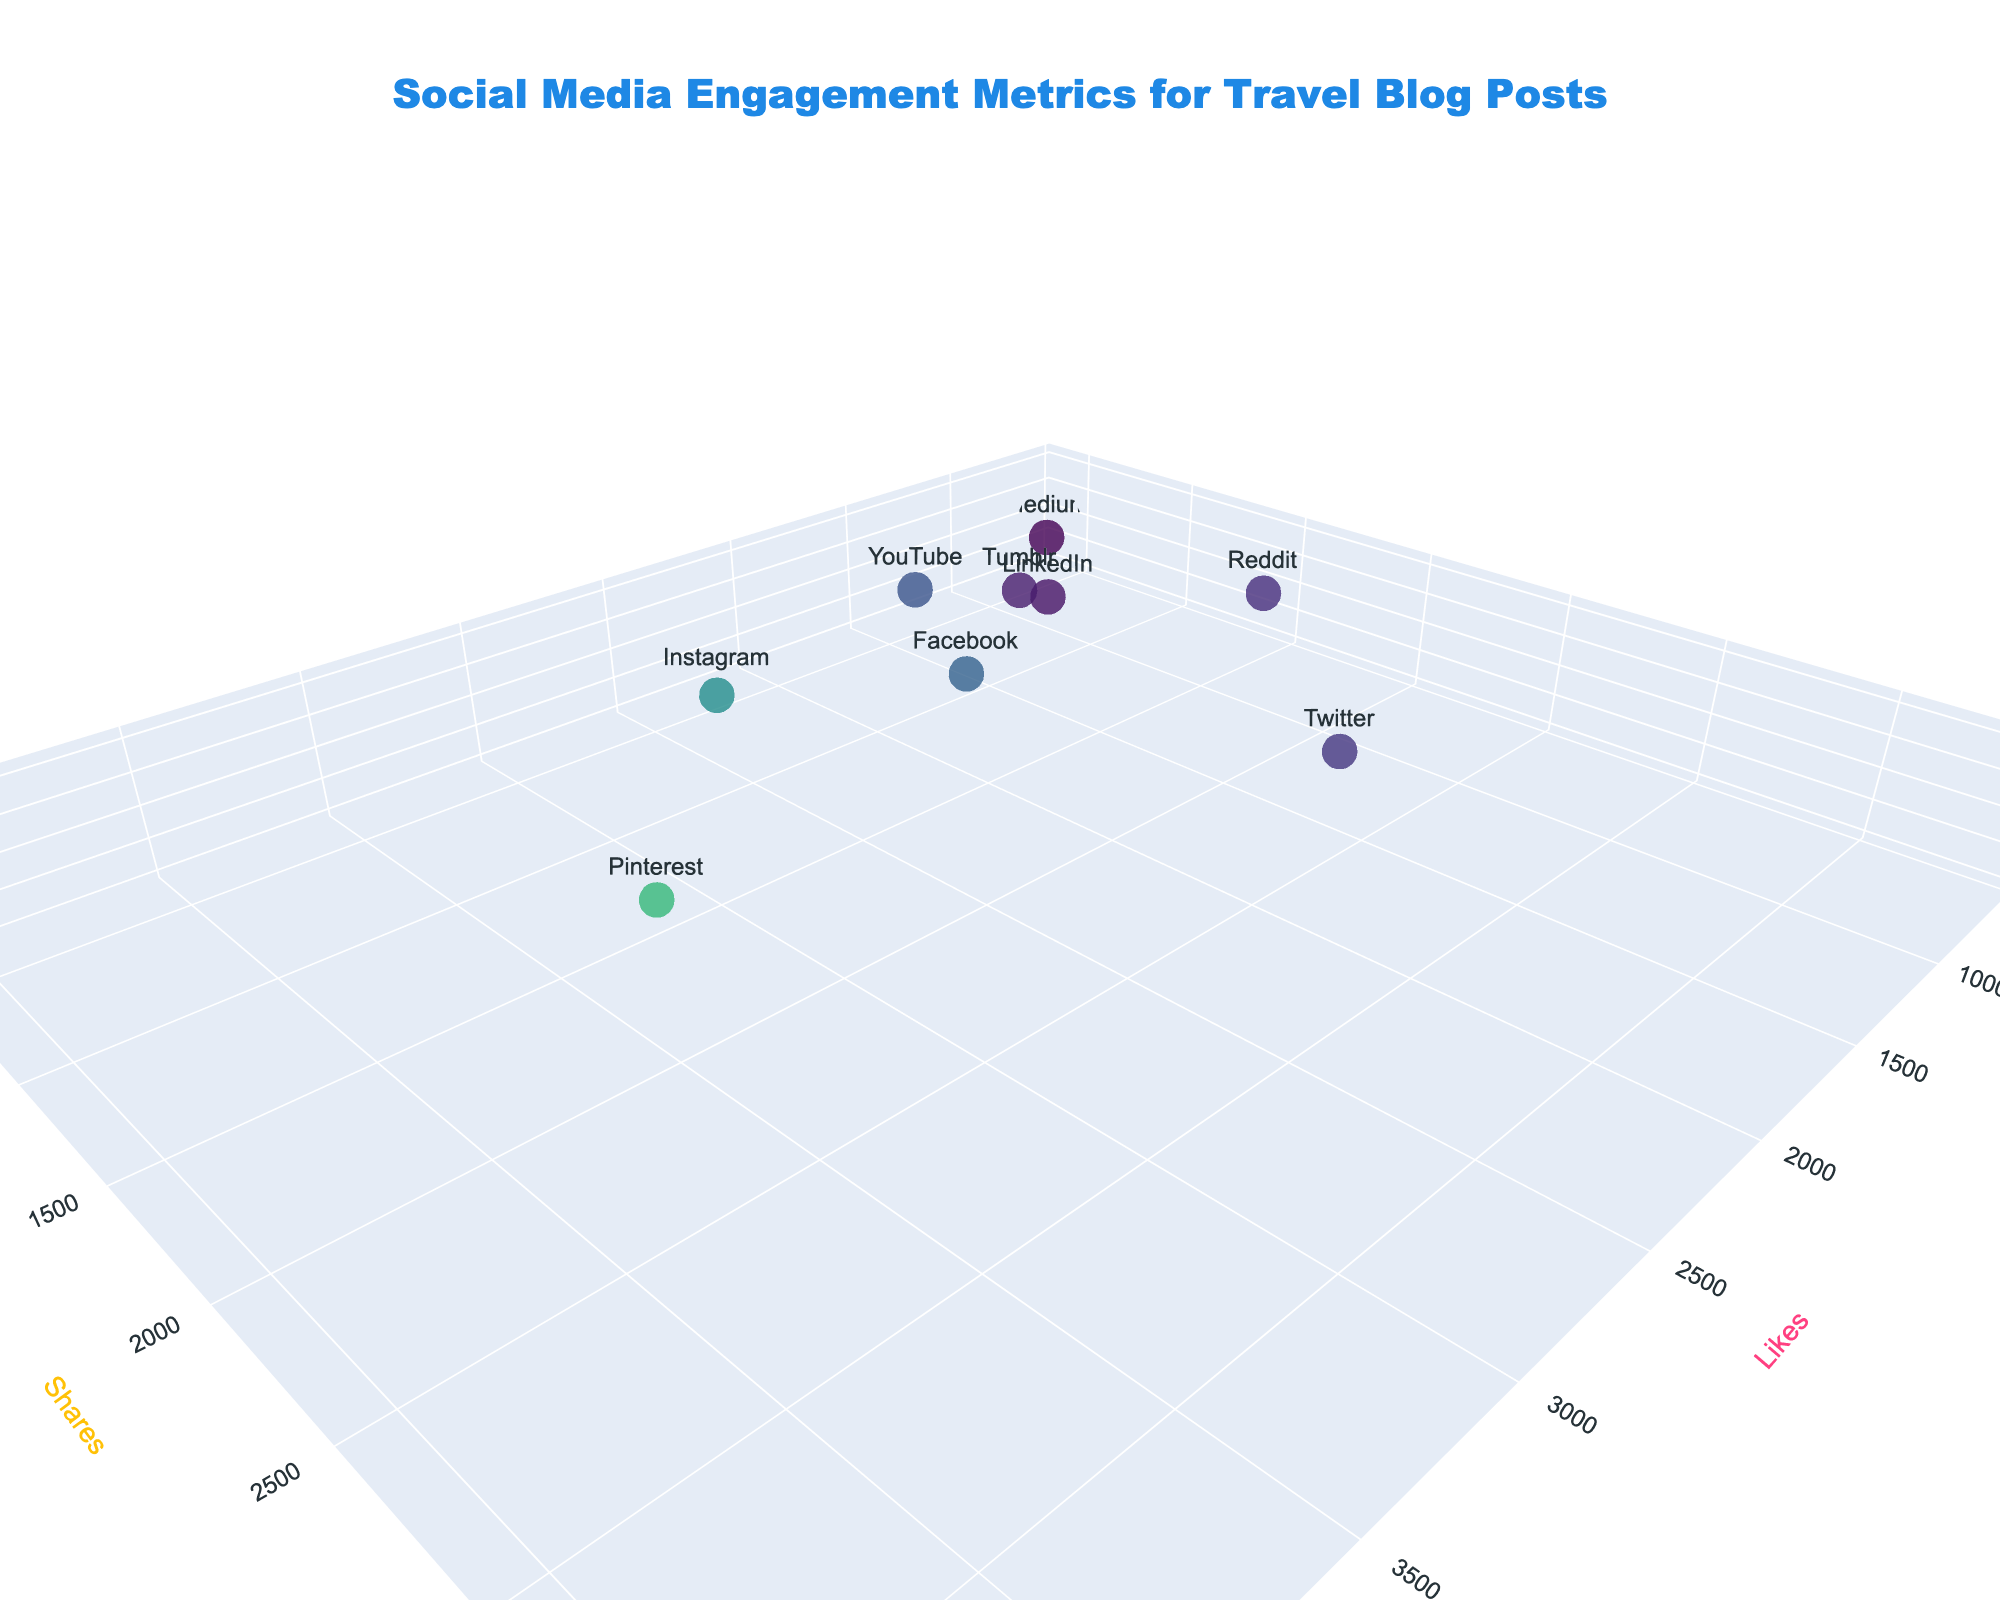what is the title of the figure? The figure's title can be found at the top center of the plot. It helps users understand the overall theme of the plot. In this case, it says "Social Media Engagement Metrics for Travel Blog Posts."
Answer: Social Media Engagement Metrics for Travel Blog Posts how many social media platforms are represented in the plot? To find the number of platforms, we can count the individual markers in the 3D plot. Alternatively, the data gives the "Platform" column, which has 10 distinct entries.
Answer: 10 which platform has the highest number of likes? Looking at the 3D plot, the platform that has the highest value along the 'Likes' axis will have the most likes. TikTok has 4500 likes, which is the highest.
Answer: TikTok which platform has the lowest number of comments? By examining the values along the 'Comments' axis, LinkedIn has the smallest value of 90 comments.
Answer: LinkedIn compare the number of shares on Facebook with Pinterest. Which platform has more shares? Find the markers representing Facebook and Pinterest. Facebook has 1200 shares, while Pinterest has 1500 shares. 1500 is greater than 1200, so Pinterest has more shares.
Answer: Pinterest what is the total number of comments across all platforms? Add up the number of comments for all listed platforms: 320 + 280 + 150 + 90 + 180 + 450 + 380 + 220 + 130 + 520. The sum is 2720.
Answer: 2720 which platform has the highest overall engagement (sum of likes, shares, and comments)? Calculate the total engagement for each platform by summing the likes, shares, and comments. TikTok has the highest engagement: (4500 + 3800 + 450 = 8750).
Answer: TikTok how does the engagement on Twitter compare to Reddit in terms of shares and comments? For shares: Twitter (2200) vs. Reddit (1800); Twitter has more shares.
For comments: Twitter (150) vs. Reddit (520); Reddit has more comments.
Answer: Twitter has more shares, Reddit has more comments what can you infer about LinkedIn based on its position in the plot? LinkedIn is positioned lower on all three axes: Likes (800), Shares (600), and Comments (90), indicating it has relatively low engagement compared to other platforms.
Answer: Relatively low engagement is there any platform with higher comments than shares? By examining the plot, there is no platform where the 'Comments' value exceeds the 'Shares' value. Each platform has more shares than comments.
Answer: No 